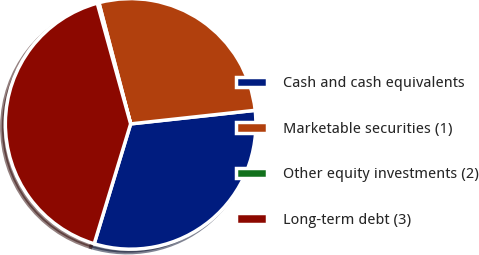<chart> <loc_0><loc_0><loc_500><loc_500><pie_chart><fcel>Cash and cash equivalents<fcel>Marketable securities (1)<fcel>Other equity investments (2)<fcel>Long-term debt (3)<nl><fcel>31.43%<fcel>27.35%<fcel>0.22%<fcel>41.01%<nl></chart> 